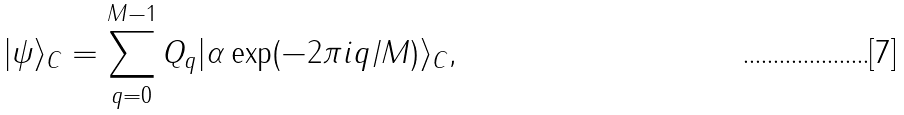<formula> <loc_0><loc_0><loc_500><loc_500>| \psi \rangle _ { C } = \sum _ { q = 0 } ^ { M - 1 } Q _ { q } | \alpha \exp ( - 2 \pi i q / M ) \rangle _ { C } ,</formula> 